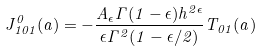<formula> <loc_0><loc_0><loc_500><loc_500>J ^ { 0 } _ { 1 0 1 } ( a ) = - \frac { A _ { \epsilon } \Gamma ( 1 - \epsilon ) h ^ { 2 \epsilon } } { \epsilon \Gamma ^ { 2 } ( 1 - \epsilon / 2 ) } T _ { 0 1 } ( a )</formula> 